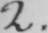Please provide the text content of this handwritten line. 2 . 